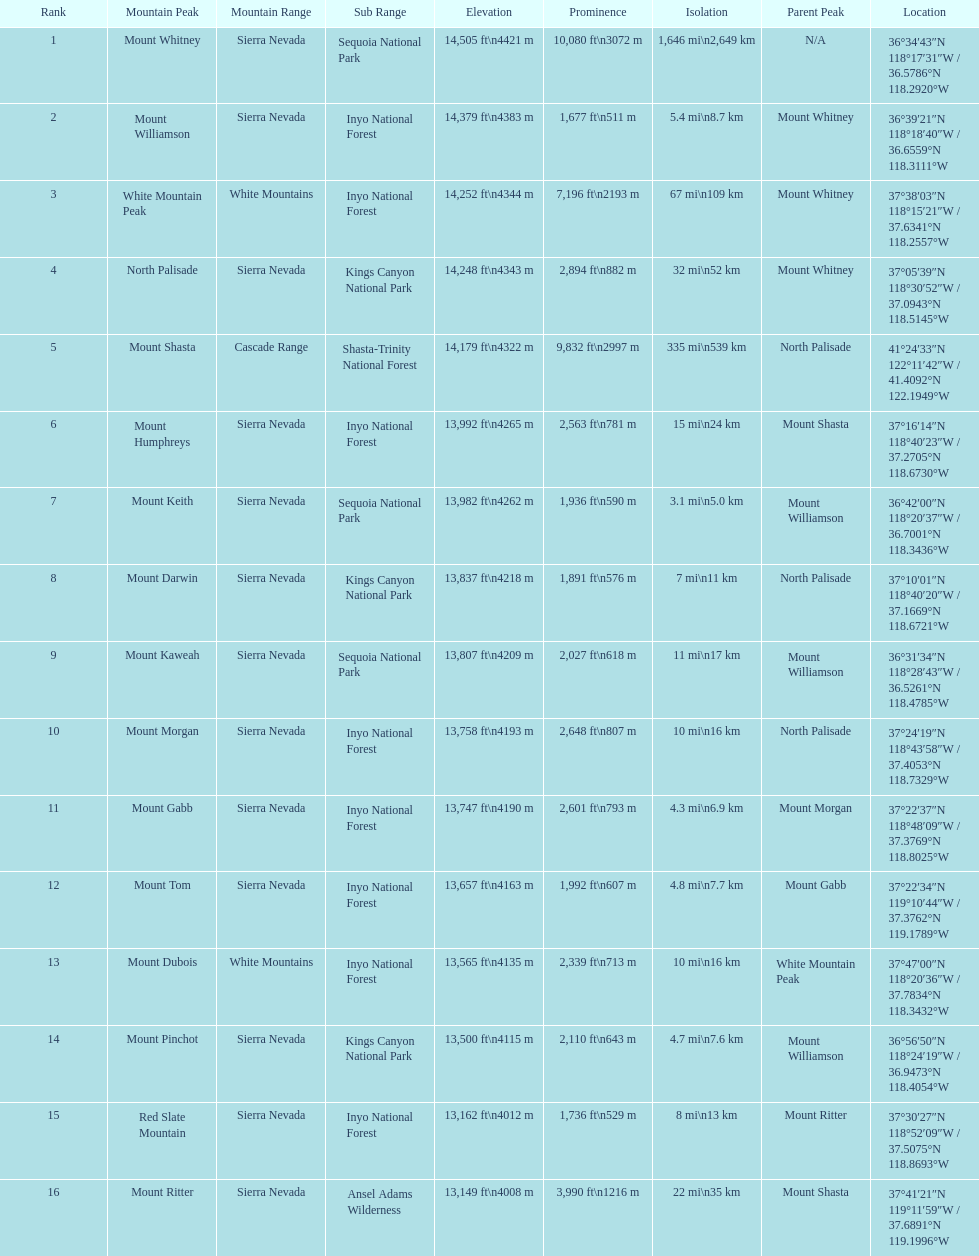Which mountain peak has a prominence more than 10,000 ft? Mount Whitney. 